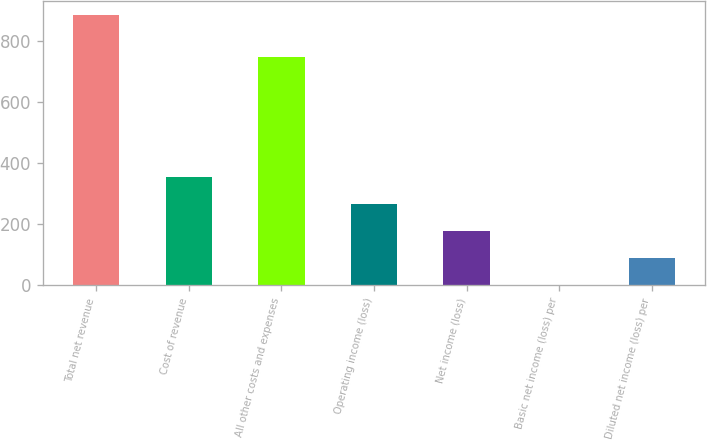<chart> <loc_0><loc_0><loc_500><loc_500><bar_chart><fcel>Total net revenue<fcel>Cost of revenue<fcel>All other costs and expenses<fcel>Operating income (loss)<fcel>Net income (loss)<fcel>Basic net income (loss) per<fcel>Diluted net income (loss) per<nl><fcel>886<fcel>354.43<fcel>747<fcel>265.84<fcel>177.25<fcel>0.07<fcel>88.66<nl></chart> 